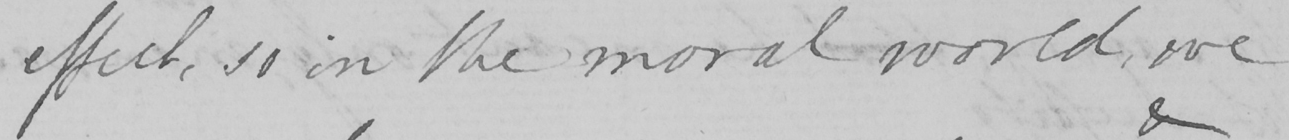What is written in this line of handwriting? effect , so in the moral world , we 